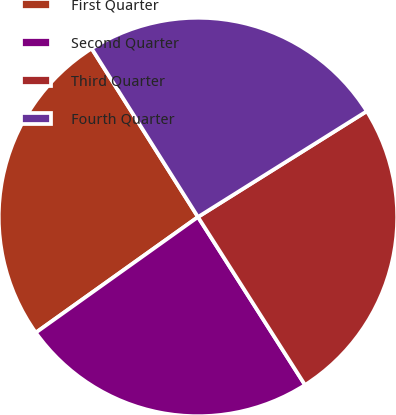Convert chart to OTSL. <chart><loc_0><loc_0><loc_500><loc_500><pie_chart><fcel>First Quarter<fcel>Second Quarter<fcel>Third Quarter<fcel>Fourth Quarter<nl><fcel>25.9%<fcel>24.17%<fcel>24.88%<fcel>25.05%<nl></chart> 